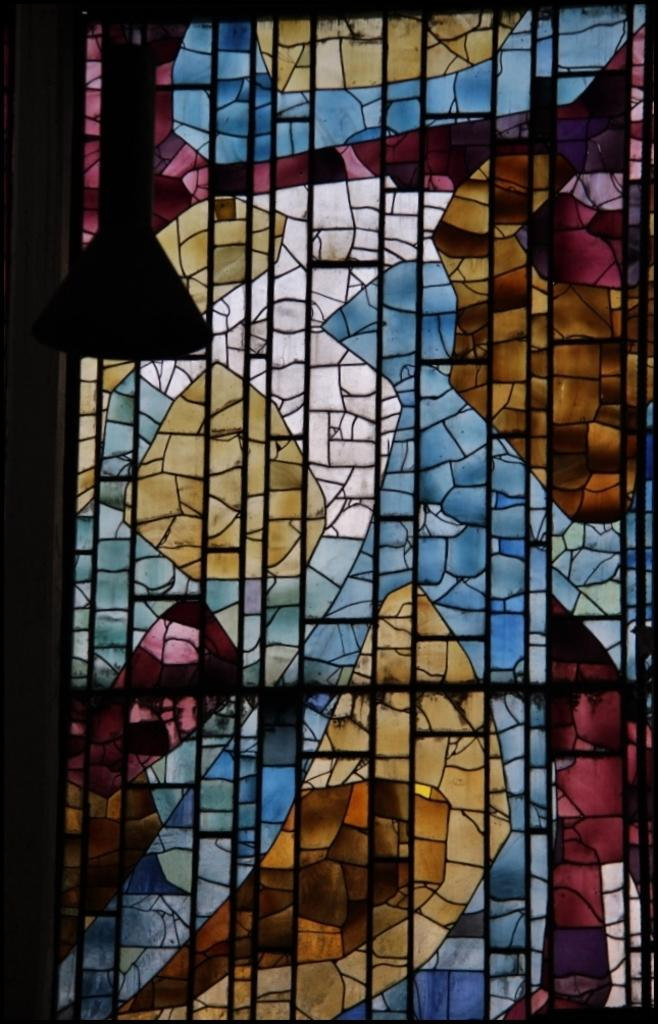What type of artwork can be seen in the background of the image? There is a stained glass in the background of the image. Can you describe the object located in the left corner of the image? Unfortunately, the provided facts do not give enough information to describe the object in the left corner of the image. What type of food is being prepared by the machine in the image? There is no machine or food present in the image. 